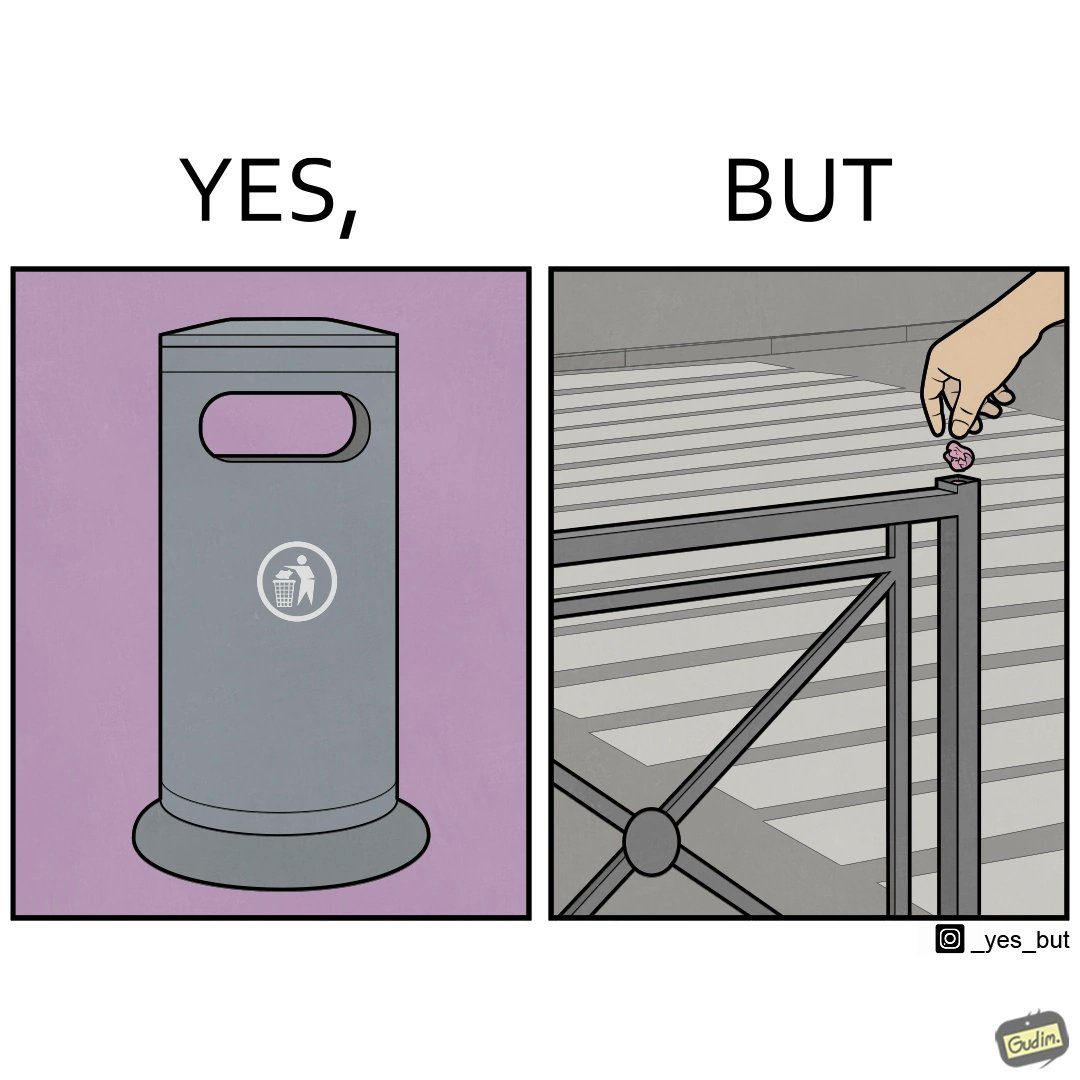Is there satirical content in this image? Yes, this image is satirical. 